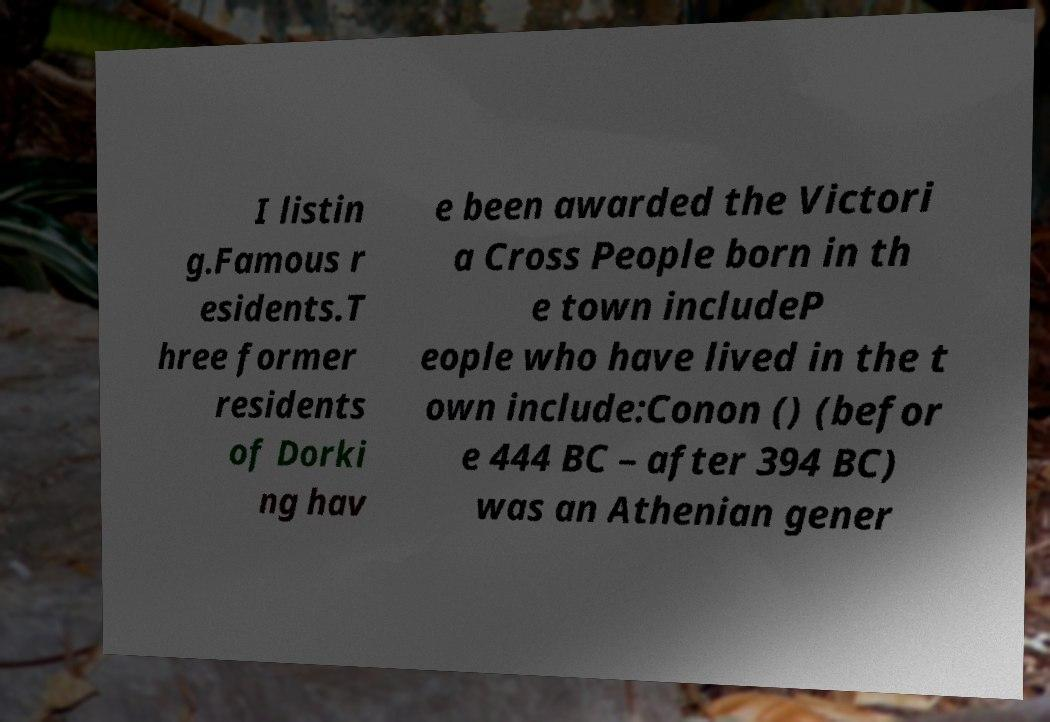Can you read and provide the text displayed in the image?This photo seems to have some interesting text. Can you extract and type it out for me? I listin g.Famous r esidents.T hree former residents of Dorki ng hav e been awarded the Victori a Cross People born in th e town includeP eople who have lived in the t own include:Conon () (befor e 444 BC – after 394 BC) was an Athenian gener 